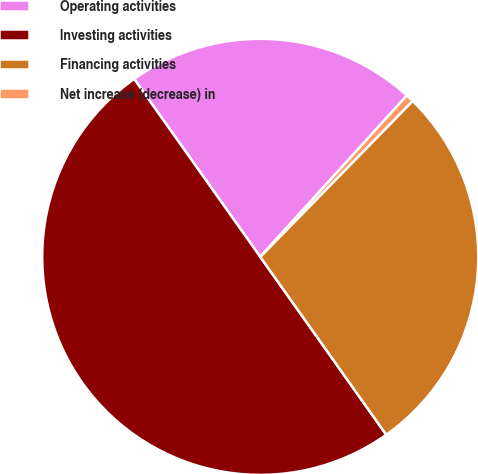Convert chart to OTSL. <chart><loc_0><loc_0><loc_500><loc_500><pie_chart><fcel>Operating activities<fcel>Investing activities<fcel>Financing activities<fcel>Net increase (decrease) in<nl><fcel>21.55%<fcel>50.0%<fcel>27.87%<fcel>0.58%<nl></chart> 